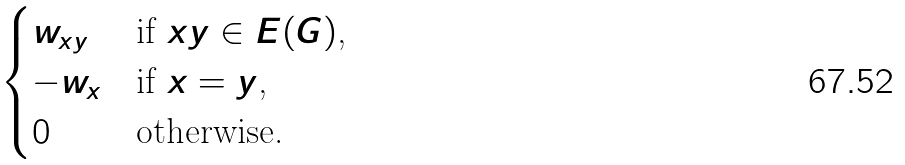Convert formula to latex. <formula><loc_0><loc_0><loc_500><loc_500>\begin{cases} w _ { x y } & \text {if $xy\in E(G)$,} \\ - w _ { x } & \text {if $x=y$,} \\ 0 & \text {otherwise.} \end{cases}</formula> 